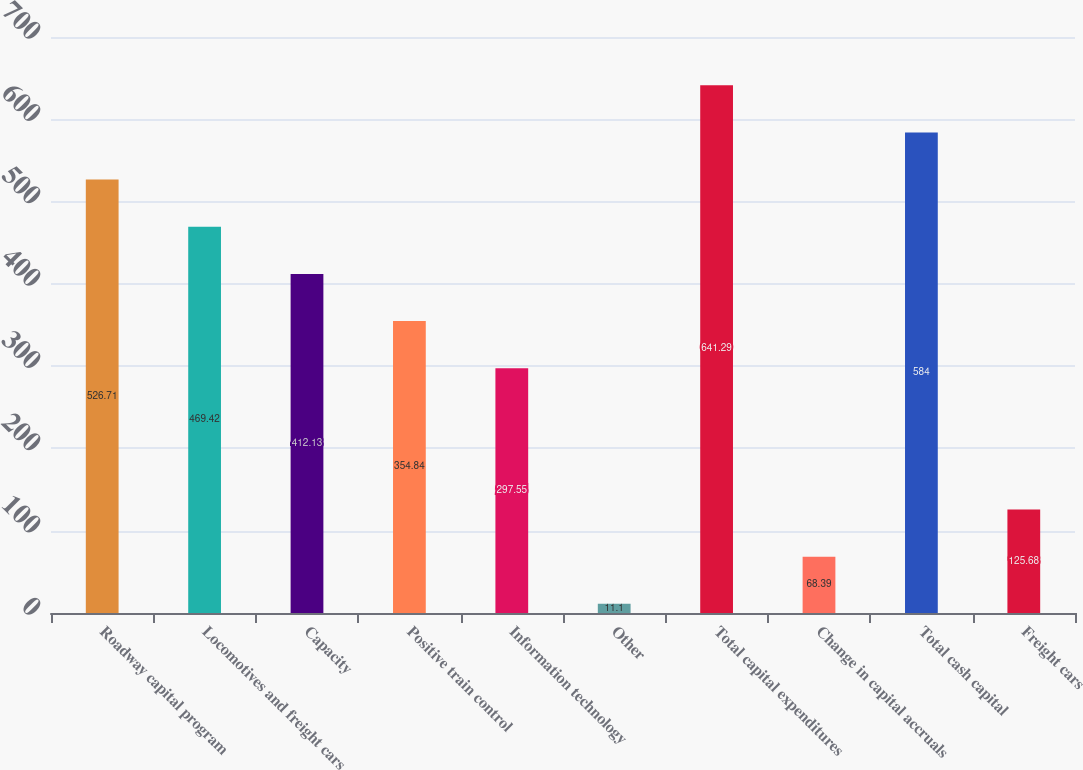Convert chart. <chart><loc_0><loc_0><loc_500><loc_500><bar_chart><fcel>Roadway capital program<fcel>Locomotives and freight cars<fcel>Capacity<fcel>Positive train control<fcel>Information technology<fcel>Other<fcel>Total capital expenditures<fcel>Change in capital accruals<fcel>Total cash capital<fcel>Freight cars<nl><fcel>526.71<fcel>469.42<fcel>412.13<fcel>354.84<fcel>297.55<fcel>11.1<fcel>641.29<fcel>68.39<fcel>584<fcel>125.68<nl></chart> 